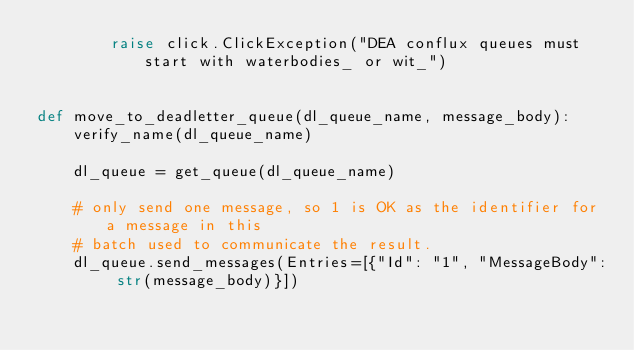Convert code to text. <code><loc_0><loc_0><loc_500><loc_500><_Python_>        raise click.ClickException("DEA conflux queues must start with waterbodies_ or wit_")


def move_to_deadletter_queue(dl_queue_name, message_body):
    verify_name(dl_queue_name)

    dl_queue = get_queue(dl_queue_name)

    # only send one message, so 1 is OK as the identifier for a message in this
    # batch used to communicate the result.
    dl_queue.send_messages(Entries=[{"Id": "1", "MessageBody": str(message_body)}])
</code> 